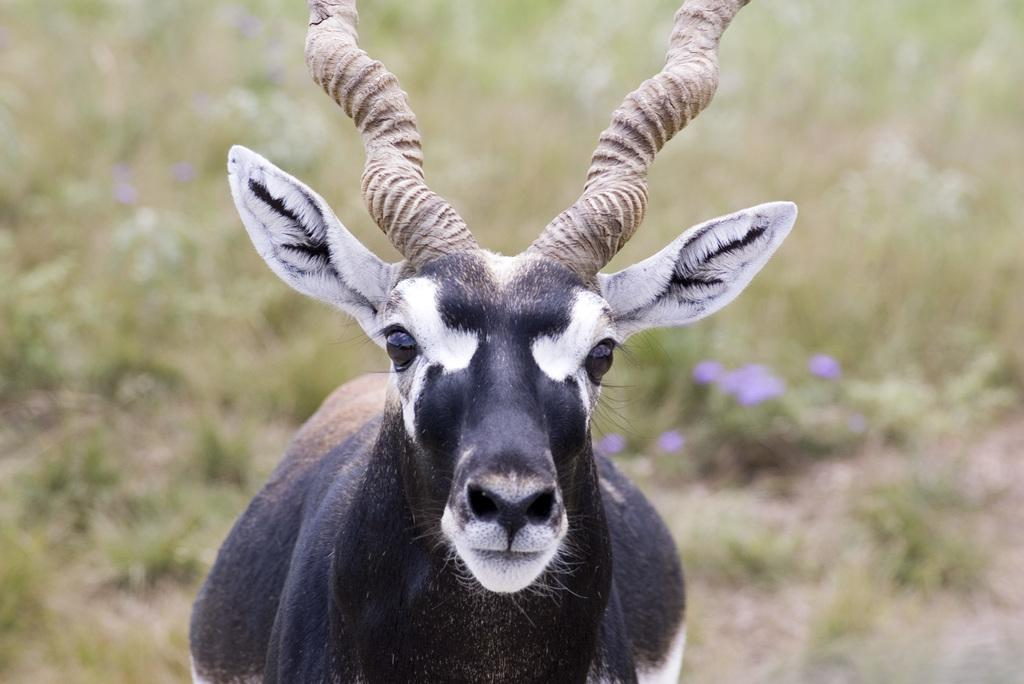What type of living creature is present in the image? There is an animal in the image. What can be seen in the background of the image? There are plants on the land in the background of the image. What type of home does the kitten live in, as depicted in the image? There is no kitten present in the image, so it is not possible to determine the type of home it might live in. 